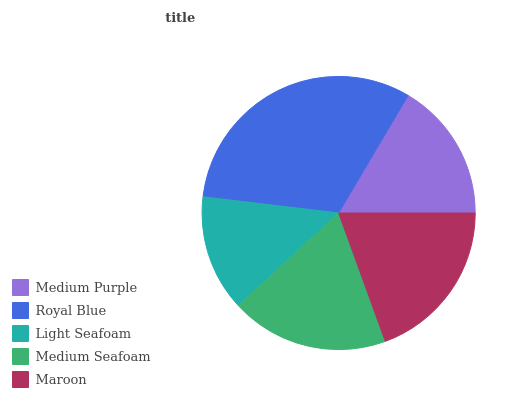Is Light Seafoam the minimum?
Answer yes or no. Yes. Is Royal Blue the maximum?
Answer yes or no. Yes. Is Royal Blue the minimum?
Answer yes or no. No. Is Light Seafoam the maximum?
Answer yes or no. No. Is Royal Blue greater than Light Seafoam?
Answer yes or no. Yes. Is Light Seafoam less than Royal Blue?
Answer yes or no. Yes. Is Light Seafoam greater than Royal Blue?
Answer yes or no. No. Is Royal Blue less than Light Seafoam?
Answer yes or no. No. Is Medium Seafoam the high median?
Answer yes or no. Yes. Is Medium Seafoam the low median?
Answer yes or no. Yes. Is Royal Blue the high median?
Answer yes or no. No. Is Light Seafoam the low median?
Answer yes or no. No. 